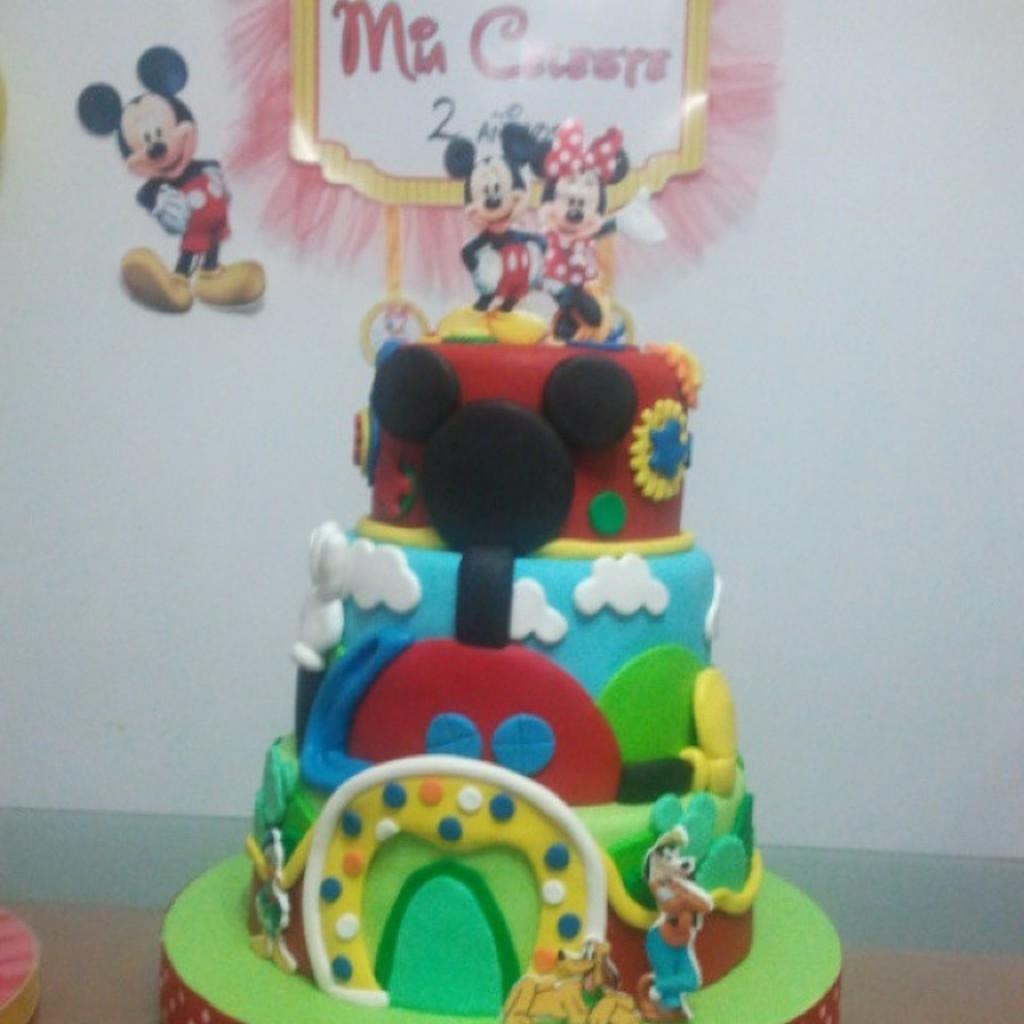What is the main subject of the image? There is a cake in the image. What decorations are on the cake? The cake has different cartoon images on images on it. What can be seen in the background of the image? There is a wall in the background of the image. What is attached to the wall in the background? There are posters attached to the wall in the background. What type of paper is being used to build a jail in the image? There is no jail or paper present in the image; it features a cake with cartoon images and a wall with posters. 